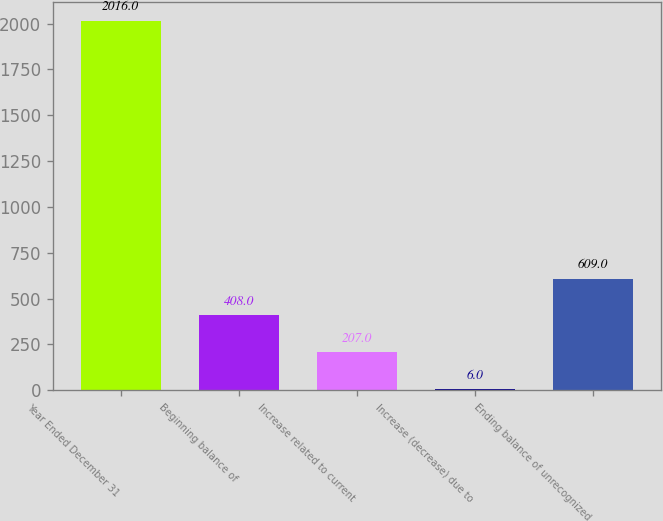Convert chart. <chart><loc_0><loc_0><loc_500><loc_500><bar_chart><fcel>Year Ended December 31<fcel>Beginning balance of<fcel>Increase related to current<fcel>Increase (decrease) due to<fcel>Ending balance of unrecognized<nl><fcel>2016<fcel>408<fcel>207<fcel>6<fcel>609<nl></chart> 